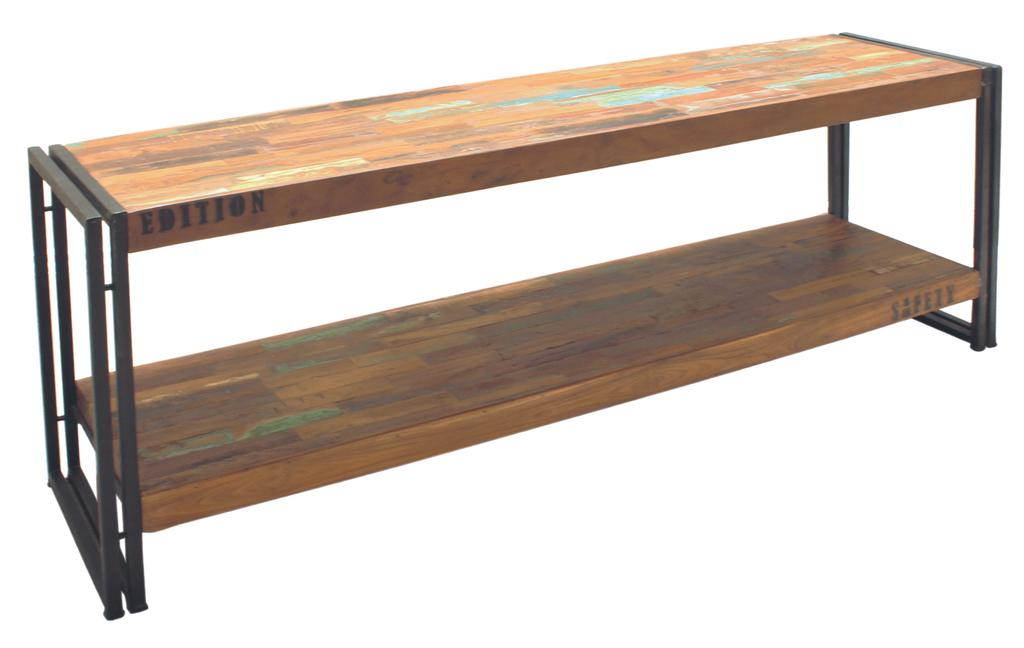<image>
Relay a brief, clear account of the picture shown. A wooden bench with the word "Edition"  on the side of top wood piece. 